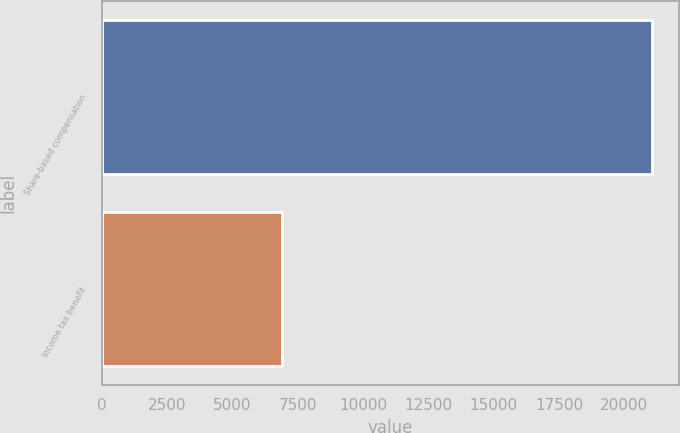Convert chart. <chart><loc_0><loc_0><loc_500><loc_500><bar_chart><fcel>Share-based compensation<fcel>Income tax benefit<nl><fcel>21056<fcel>6907<nl></chart> 